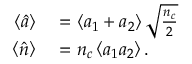Convert formula to latex. <formula><loc_0><loc_0><loc_500><loc_500>\begin{array} { r l } { \left \langle \hat { a } \right \rangle } & = \left \langle a _ { 1 } + a _ { 2 } \right \rangle \sqrt { \frac { n _ { c } } { 2 } } } \\ { \left \langle \hat { n } \right \rangle } & = n _ { c } \left \langle a _ { 1 } a _ { 2 } \right \rangle . } \end{array}</formula> 